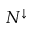<formula> <loc_0><loc_0><loc_500><loc_500>N ^ { \downarrow }</formula> 